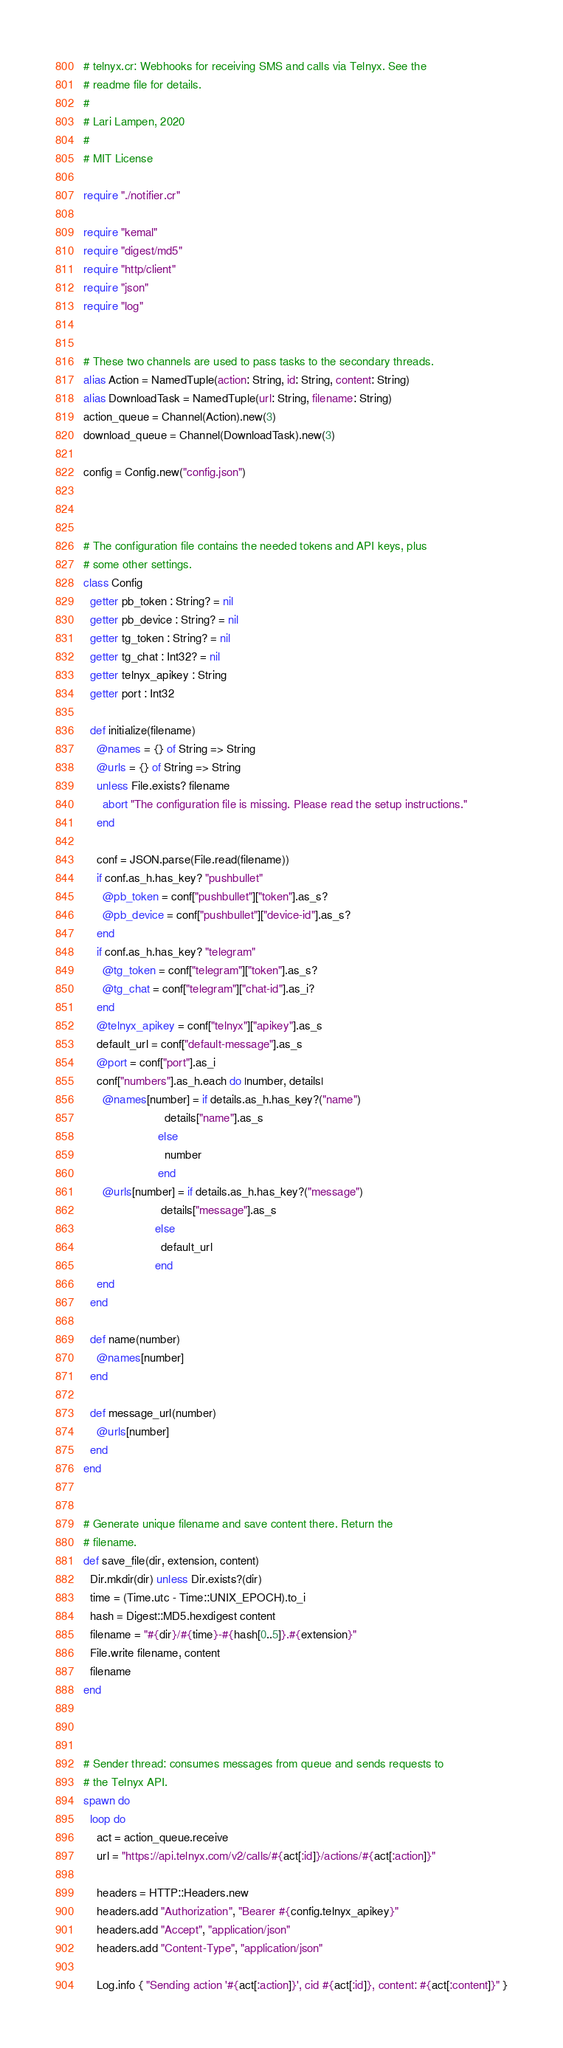Convert code to text. <code><loc_0><loc_0><loc_500><loc_500><_Crystal_># telnyx.cr: Webhooks for receiving SMS and calls via Telnyx. See the
# readme file for details.
#
# Lari Lampen, 2020
#
# MIT License

require "./notifier.cr"

require "kemal"
require "digest/md5"
require "http/client"
require "json"
require "log"


# These two channels are used to pass tasks to the secondary threads.
alias Action = NamedTuple(action: String, id: String, content: String)
alias DownloadTask = NamedTuple(url: String, filename: String)
action_queue = Channel(Action).new(3)
download_queue = Channel(DownloadTask).new(3)

config = Config.new("config.json")



# The configuration file contains the needed tokens and API keys, plus
# some other settings.
class Config
  getter pb_token : String? = nil
  getter pb_device : String? = nil
  getter tg_token : String? = nil
  getter tg_chat : Int32? = nil
  getter telnyx_apikey : String
  getter port : Int32

  def initialize(filename)
    @names = {} of String => String
    @urls = {} of String => String
    unless File.exists? filename
      abort "The configuration file is missing. Please read the setup instructions."
    end

    conf = JSON.parse(File.read(filename))
    if conf.as_h.has_key? "pushbullet"
      @pb_token = conf["pushbullet"]["token"].as_s?
      @pb_device = conf["pushbullet"]["device-id"].as_s?
    end
    if conf.as_h.has_key? "telegram"
      @tg_token = conf["telegram"]["token"].as_s?
      @tg_chat = conf["telegram"]["chat-id"].as_i?
    end
    @telnyx_apikey = conf["telnyx"]["apikey"].as_s
    default_url = conf["default-message"].as_s
    @port = conf["port"].as_i
    conf["numbers"].as_h.each do |number, details|
      @names[number] = if details.as_h.has_key?("name")
                         details["name"].as_s
                       else
                         number
                       end
      @urls[number] = if details.as_h.has_key?("message")
                        details["message"].as_s
                      else
                        default_url
                      end
    end
  end

  def name(number)
    @names[number]
  end

  def message_url(number)
    @urls[number]
  end
end


# Generate unique filename and save content there. Return the
# filename.
def save_file(dir, extension, content)
  Dir.mkdir(dir) unless Dir.exists?(dir)
  time = (Time.utc - Time::UNIX_EPOCH).to_i
  hash = Digest::MD5.hexdigest content
  filename = "#{dir}/#{time}-#{hash[0..5]}.#{extension}"
  File.write filename, content
  filename
end



# Sender thread: consumes messages from queue and sends requests to
# the Telnyx API.
spawn do
  loop do
    act = action_queue.receive
    url = "https://api.telnyx.com/v2/calls/#{act[:id]}/actions/#{act[:action]}"

    headers = HTTP::Headers.new
    headers.add "Authorization", "Bearer #{config.telnyx_apikey}"
    headers.add "Accept", "application/json"
    headers.add "Content-Type", "application/json"

    Log.info { "Sending action '#{act[:action]}', cid #{act[:id]}, content: #{act[:content]}" }</code> 